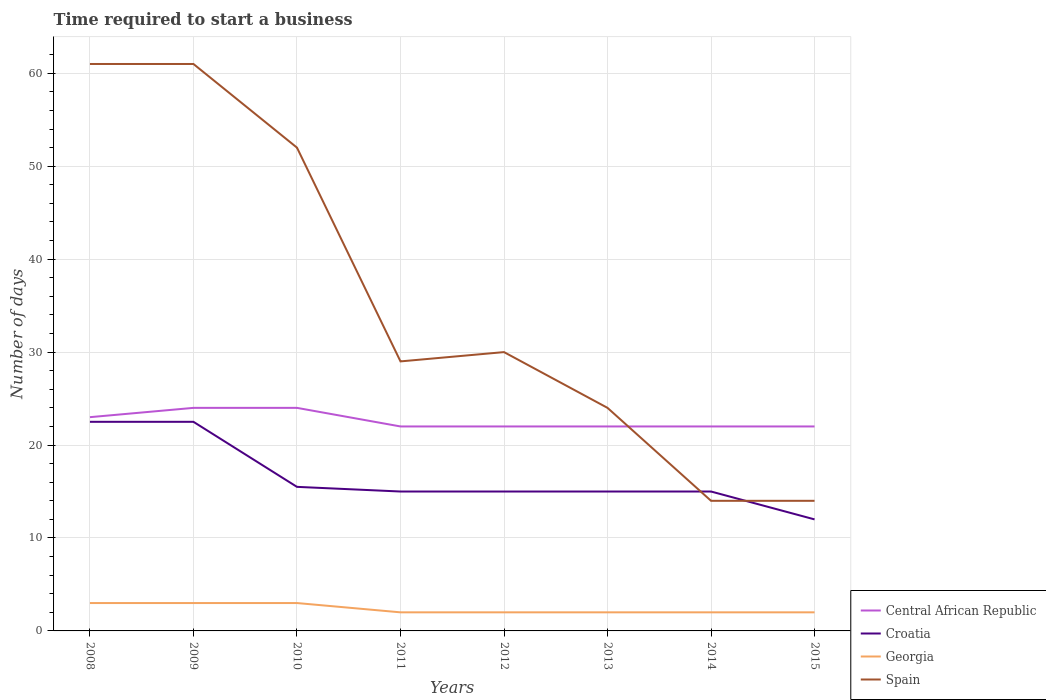Across all years, what is the maximum number of days required to start a business in Georgia?
Provide a succinct answer. 2. What is the total number of days required to start a business in Georgia in the graph?
Keep it short and to the point. 1. What is the difference between the highest and the lowest number of days required to start a business in Spain?
Your answer should be very brief. 3. Is the number of days required to start a business in Spain strictly greater than the number of days required to start a business in Georgia over the years?
Provide a succinct answer. No. Are the values on the major ticks of Y-axis written in scientific E-notation?
Offer a very short reply. No. Does the graph contain any zero values?
Keep it short and to the point. No. How many legend labels are there?
Your answer should be very brief. 4. How are the legend labels stacked?
Provide a short and direct response. Vertical. What is the title of the graph?
Your answer should be very brief. Time required to start a business. Does "Morocco" appear as one of the legend labels in the graph?
Provide a succinct answer. No. What is the label or title of the X-axis?
Offer a terse response. Years. What is the label or title of the Y-axis?
Provide a short and direct response. Number of days. What is the Number of days in Central African Republic in 2009?
Ensure brevity in your answer.  24. What is the Number of days of Georgia in 2009?
Offer a very short reply. 3. What is the Number of days in Spain in 2009?
Keep it short and to the point. 61. What is the Number of days of Georgia in 2010?
Make the answer very short. 3. What is the Number of days in Spain in 2010?
Ensure brevity in your answer.  52. What is the Number of days of Croatia in 2011?
Offer a terse response. 15. What is the Number of days in Central African Republic in 2012?
Give a very brief answer. 22. What is the Number of days of Spain in 2012?
Your answer should be compact. 30. What is the Number of days in Central African Republic in 2013?
Offer a very short reply. 22. What is the Number of days in Croatia in 2013?
Your response must be concise. 15. What is the Number of days in Spain in 2013?
Offer a terse response. 24. What is the Number of days of Croatia in 2014?
Your answer should be very brief. 15. What is the Number of days in Georgia in 2014?
Give a very brief answer. 2. What is the Number of days in Central African Republic in 2015?
Keep it short and to the point. 22. What is the Number of days in Croatia in 2015?
Provide a succinct answer. 12. What is the Number of days in Georgia in 2015?
Provide a succinct answer. 2. Across all years, what is the maximum Number of days of Croatia?
Your response must be concise. 22.5. Across all years, what is the maximum Number of days of Georgia?
Keep it short and to the point. 3. Across all years, what is the minimum Number of days in Central African Republic?
Keep it short and to the point. 22. Across all years, what is the minimum Number of days of Georgia?
Your response must be concise. 2. Across all years, what is the minimum Number of days of Spain?
Ensure brevity in your answer.  14. What is the total Number of days of Central African Republic in the graph?
Provide a short and direct response. 181. What is the total Number of days in Croatia in the graph?
Give a very brief answer. 132.5. What is the total Number of days of Georgia in the graph?
Offer a very short reply. 19. What is the total Number of days in Spain in the graph?
Ensure brevity in your answer.  285. What is the difference between the Number of days in Georgia in 2008 and that in 2010?
Provide a succinct answer. 0. What is the difference between the Number of days of Spain in 2008 and that in 2010?
Offer a terse response. 9. What is the difference between the Number of days of Central African Republic in 2008 and that in 2011?
Provide a succinct answer. 1. What is the difference between the Number of days in Croatia in 2008 and that in 2011?
Provide a short and direct response. 7.5. What is the difference between the Number of days of Georgia in 2008 and that in 2011?
Your answer should be very brief. 1. What is the difference between the Number of days of Spain in 2008 and that in 2012?
Ensure brevity in your answer.  31. What is the difference between the Number of days in Central African Republic in 2008 and that in 2013?
Keep it short and to the point. 1. What is the difference between the Number of days of Croatia in 2008 and that in 2014?
Your answer should be compact. 7.5. What is the difference between the Number of days in Spain in 2008 and that in 2015?
Give a very brief answer. 47. What is the difference between the Number of days of Central African Republic in 2009 and that in 2010?
Offer a very short reply. 0. What is the difference between the Number of days in Croatia in 2009 and that in 2010?
Provide a short and direct response. 7. What is the difference between the Number of days of Georgia in 2009 and that in 2010?
Make the answer very short. 0. What is the difference between the Number of days of Croatia in 2009 and that in 2011?
Your answer should be compact. 7.5. What is the difference between the Number of days of Spain in 2009 and that in 2011?
Ensure brevity in your answer.  32. What is the difference between the Number of days of Central African Republic in 2009 and that in 2012?
Ensure brevity in your answer.  2. What is the difference between the Number of days of Croatia in 2009 and that in 2012?
Make the answer very short. 7.5. What is the difference between the Number of days of Georgia in 2009 and that in 2012?
Keep it short and to the point. 1. What is the difference between the Number of days of Georgia in 2009 and that in 2013?
Provide a succinct answer. 1. What is the difference between the Number of days in Central African Republic in 2009 and that in 2014?
Offer a very short reply. 2. What is the difference between the Number of days in Georgia in 2009 and that in 2014?
Provide a succinct answer. 1. What is the difference between the Number of days of Central African Republic in 2009 and that in 2015?
Ensure brevity in your answer.  2. What is the difference between the Number of days of Spain in 2009 and that in 2015?
Your response must be concise. 47. What is the difference between the Number of days of Central African Republic in 2010 and that in 2011?
Offer a very short reply. 2. What is the difference between the Number of days of Georgia in 2010 and that in 2011?
Offer a very short reply. 1. What is the difference between the Number of days of Spain in 2010 and that in 2011?
Provide a short and direct response. 23. What is the difference between the Number of days in Central African Republic in 2010 and that in 2012?
Give a very brief answer. 2. What is the difference between the Number of days in Spain in 2010 and that in 2012?
Your response must be concise. 22. What is the difference between the Number of days of Central African Republic in 2010 and that in 2013?
Keep it short and to the point. 2. What is the difference between the Number of days in Croatia in 2010 and that in 2013?
Ensure brevity in your answer.  0.5. What is the difference between the Number of days of Spain in 2010 and that in 2013?
Your response must be concise. 28. What is the difference between the Number of days of Central African Republic in 2010 and that in 2014?
Ensure brevity in your answer.  2. What is the difference between the Number of days of Croatia in 2010 and that in 2014?
Keep it short and to the point. 0.5. What is the difference between the Number of days of Spain in 2010 and that in 2014?
Offer a terse response. 38. What is the difference between the Number of days in Central African Republic in 2010 and that in 2015?
Your response must be concise. 2. What is the difference between the Number of days of Central African Republic in 2011 and that in 2012?
Offer a terse response. 0. What is the difference between the Number of days in Croatia in 2011 and that in 2012?
Your response must be concise. 0. What is the difference between the Number of days in Spain in 2011 and that in 2012?
Offer a very short reply. -1. What is the difference between the Number of days in Spain in 2011 and that in 2013?
Make the answer very short. 5. What is the difference between the Number of days in Spain in 2011 and that in 2014?
Ensure brevity in your answer.  15. What is the difference between the Number of days of Croatia in 2011 and that in 2015?
Offer a terse response. 3. What is the difference between the Number of days of Spain in 2011 and that in 2015?
Your response must be concise. 15. What is the difference between the Number of days in Georgia in 2012 and that in 2013?
Offer a very short reply. 0. What is the difference between the Number of days in Spain in 2012 and that in 2014?
Ensure brevity in your answer.  16. What is the difference between the Number of days of Central African Republic in 2012 and that in 2015?
Make the answer very short. 0. What is the difference between the Number of days of Georgia in 2012 and that in 2015?
Your response must be concise. 0. What is the difference between the Number of days in Croatia in 2013 and that in 2014?
Offer a terse response. 0. What is the difference between the Number of days in Georgia in 2013 and that in 2014?
Make the answer very short. 0. What is the difference between the Number of days in Croatia in 2013 and that in 2015?
Offer a terse response. 3. What is the difference between the Number of days in Georgia in 2013 and that in 2015?
Provide a short and direct response. 0. What is the difference between the Number of days of Spain in 2013 and that in 2015?
Your answer should be compact. 10. What is the difference between the Number of days in Central African Republic in 2014 and that in 2015?
Offer a very short reply. 0. What is the difference between the Number of days in Georgia in 2014 and that in 2015?
Your answer should be very brief. 0. What is the difference between the Number of days in Central African Republic in 2008 and the Number of days in Spain in 2009?
Your response must be concise. -38. What is the difference between the Number of days of Croatia in 2008 and the Number of days of Georgia in 2009?
Your answer should be very brief. 19.5. What is the difference between the Number of days in Croatia in 2008 and the Number of days in Spain in 2009?
Give a very brief answer. -38.5. What is the difference between the Number of days in Georgia in 2008 and the Number of days in Spain in 2009?
Make the answer very short. -58. What is the difference between the Number of days in Croatia in 2008 and the Number of days in Georgia in 2010?
Your response must be concise. 19.5. What is the difference between the Number of days of Croatia in 2008 and the Number of days of Spain in 2010?
Your answer should be very brief. -29.5. What is the difference between the Number of days in Georgia in 2008 and the Number of days in Spain in 2010?
Make the answer very short. -49. What is the difference between the Number of days of Central African Republic in 2008 and the Number of days of Georgia in 2011?
Offer a very short reply. 21. What is the difference between the Number of days of Croatia in 2008 and the Number of days of Georgia in 2011?
Your response must be concise. 20.5. What is the difference between the Number of days of Georgia in 2008 and the Number of days of Spain in 2011?
Your answer should be compact. -26. What is the difference between the Number of days of Central African Republic in 2008 and the Number of days of Croatia in 2012?
Offer a very short reply. 8. What is the difference between the Number of days of Central African Republic in 2008 and the Number of days of Georgia in 2012?
Provide a short and direct response. 21. What is the difference between the Number of days in Croatia in 2008 and the Number of days in Spain in 2012?
Provide a short and direct response. -7.5. What is the difference between the Number of days of Georgia in 2008 and the Number of days of Spain in 2012?
Provide a succinct answer. -27. What is the difference between the Number of days in Croatia in 2008 and the Number of days in Georgia in 2013?
Ensure brevity in your answer.  20.5. What is the difference between the Number of days in Georgia in 2008 and the Number of days in Spain in 2013?
Give a very brief answer. -21. What is the difference between the Number of days in Central African Republic in 2008 and the Number of days in Georgia in 2014?
Your answer should be very brief. 21. What is the difference between the Number of days of Central African Republic in 2008 and the Number of days of Spain in 2014?
Keep it short and to the point. 9. What is the difference between the Number of days of Croatia in 2008 and the Number of days of Spain in 2014?
Provide a short and direct response. 8.5. What is the difference between the Number of days in Georgia in 2008 and the Number of days in Spain in 2014?
Provide a short and direct response. -11. What is the difference between the Number of days in Central African Republic in 2008 and the Number of days in Croatia in 2015?
Make the answer very short. 11. What is the difference between the Number of days in Central African Republic in 2008 and the Number of days in Georgia in 2015?
Offer a very short reply. 21. What is the difference between the Number of days in Central African Republic in 2008 and the Number of days in Spain in 2015?
Offer a very short reply. 9. What is the difference between the Number of days in Georgia in 2008 and the Number of days in Spain in 2015?
Give a very brief answer. -11. What is the difference between the Number of days in Central African Republic in 2009 and the Number of days in Croatia in 2010?
Offer a terse response. 8.5. What is the difference between the Number of days of Central African Republic in 2009 and the Number of days of Georgia in 2010?
Make the answer very short. 21. What is the difference between the Number of days of Central African Republic in 2009 and the Number of days of Spain in 2010?
Keep it short and to the point. -28. What is the difference between the Number of days in Croatia in 2009 and the Number of days in Georgia in 2010?
Provide a short and direct response. 19.5. What is the difference between the Number of days of Croatia in 2009 and the Number of days of Spain in 2010?
Offer a terse response. -29.5. What is the difference between the Number of days in Georgia in 2009 and the Number of days in Spain in 2010?
Offer a terse response. -49. What is the difference between the Number of days in Central African Republic in 2009 and the Number of days in Georgia in 2011?
Your response must be concise. 22. What is the difference between the Number of days of Central African Republic in 2009 and the Number of days of Croatia in 2012?
Offer a terse response. 9. What is the difference between the Number of days of Central African Republic in 2009 and the Number of days of Georgia in 2012?
Offer a terse response. 22. What is the difference between the Number of days in Central African Republic in 2009 and the Number of days in Spain in 2012?
Your answer should be very brief. -6. What is the difference between the Number of days in Croatia in 2009 and the Number of days in Spain in 2012?
Give a very brief answer. -7.5. What is the difference between the Number of days of Georgia in 2009 and the Number of days of Spain in 2012?
Provide a succinct answer. -27. What is the difference between the Number of days in Central African Republic in 2009 and the Number of days in Croatia in 2014?
Ensure brevity in your answer.  9. What is the difference between the Number of days in Central African Republic in 2009 and the Number of days in Georgia in 2014?
Provide a short and direct response. 22. What is the difference between the Number of days in Central African Republic in 2009 and the Number of days in Spain in 2014?
Your answer should be very brief. 10. What is the difference between the Number of days of Croatia in 2009 and the Number of days of Georgia in 2014?
Your response must be concise. 20.5. What is the difference between the Number of days in Croatia in 2009 and the Number of days in Spain in 2015?
Give a very brief answer. 8.5. What is the difference between the Number of days in Central African Republic in 2010 and the Number of days in Croatia in 2011?
Offer a very short reply. 9. What is the difference between the Number of days of Central African Republic in 2010 and the Number of days of Georgia in 2011?
Your answer should be very brief. 22. What is the difference between the Number of days of Central African Republic in 2010 and the Number of days of Spain in 2011?
Keep it short and to the point. -5. What is the difference between the Number of days of Croatia in 2010 and the Number of days of Georgia in 2011?
Ensure brevity in your answer.  13.5. What is the difference between the Number of days of Georgia in 2010 and the Number of days of Spain in 2011?
Ensure brevity in your answer.  -26. What is the difference between the Number of days of Central African Republic in 2010 and the Number of days of Spain in 2012?
Provide a short and direct response. -6. What is the difference between the Number of days in Croatia in 2010 and the Number of days in Georgia in 2013?
Make the answer very short. 13.5. What is the difference between the Number of days in Georgia in 2010 and the Number of days in Spain in 2013?
Provide a succinct answer. -21. What is the difference between the Number of days of Georgia in 2010 and the Number of days of Spain in 2014?
Give a very brief answer. -11. What is the difference between the Number of days in Central African Republic in 2010 and the Number of days in Croatia in 2015?
Your answer should be very brief. 12. What is the difference between the Number of days in Central African Republic in 2010 and the Number of days in Spain in 2015?
Offer a terse response. 10. What is the difference between the Number of days of Croatia in 2010 and the Number of days of Spain in 2015?
Make the answer very short. 1.5. What is the difference between the Number of days of Croatia in 2011 and the Number of days of Spain in 2012?
Offer a very short reply. -15. What is the difference between the Number of days in Georgia in 2011 and the Number of days in Spain in 2012?
Your answer should be very brief. -28. What is the difference between the Number of days of Central African Republic in 2011 and the Number of days of Georgia in 2013?
Your answer should be compact. 20. What is the difference between the Number of days in Central African Republic in 2011 and the Number of days in Spain in 2013?
Ensure brevity in your answer.  -2. What is the difference between the Number of days in Croatia in 2011 and the Number of days in Spain in 2013?
Ensure brevity in your answer.  -9. What is the difference between the Number of days in Central African Republic in 2011 and the Number of days in Spain in 2014?
Your answer should be compact. 8. What is the difference between the Number of days of Croatia in 2011 and the Number of days of Georgia in 2015?
Provide a succinct answer. 13. What is the difference between the Number of days of Croatia in 2011 and the Number of days of Spain in 2015?
Offer a terse response. 1. What is the difference between the Number of days of Central African Republic in 2012 and the Number of days of Croatia in 2013?
Your answer should be very brief. 7. What is the difference between the Number of days of Central African Republic in 2012 and the Number of days of Georgia in 2013?
Give a very brief answer. 20. What is the difference between the Number of days of Central African Republic in 2012 and the Number of days of Spain in 2013?
Give a very brief answer. -2. What is the difference between the Number of days in Croatia in 2012 and the Number of days in Georgia in 2013?
Your answer should be compact. 13. What is the difference between the Number of days of Croatia in 2012 and the Number of days of Spain in 2013?
Offer a terse response. -9. What is the difference between the Number of days in Georgia in 2012 and the Number of days in Spain in 2013?
Your answer should be compact. -22. What is the difference between the Number of days of Central African Republic in 2012 and the Number of days of Croatia in 2014?
Give a very brief answer. 7. What is the difference between the Number of days of Central African Republic in 2012 and the Number of days of Georgia in 2014?
Ensure brevity in your answer.  20. What is the difference between the Number of days in Central African Republic in 2012 and the Number of days in Spain in 2014?
Provide a short and direct response. 8. What is the difference between the Number of days in Croatia in 2012 and the Number of days in Spain in 2014?
Keep it short and to the point. 1. What is the difference between the Number of days in Georgia in 2012 and the Number of days in Spain in 2014?
Offer a very short reply. -12. What is the difference between the Number of days in Central African Republic in 2012 and the Number of days in Croatia in 2015?
Your answer should be very brief. 10. What is the difference between the Number of days in Central African Republic in 2012 and the Number of days in Georgia in 2015?
Make the answer very short. 20. What is the difference between the Number of days in Croatia in 2012 and the Number of days in Georgia in 2015?
Offer a very short reply. 13. What is the difference between the Number of days in Croatia in 2012 and the Number of days in Spain in 2015?
Provide a short and direct response. 1. What is the difference between the Number of days of Georgia in 2012 and the Number of days of Spain in 2015?
Ensure brevity in your answer.  -12. What is the difference between the Number of days of Central African Republic in 2013 and the Number of days of Spain in 2014?
Give a very brief answer. 8. What is the difference between the Number of days in Croatia in 2013 and the Number of days in Spain in 2014?
Make the answer very short. 1. What is the difference between the Number of days in Georgia in 2013 and the Number of days in Spain in 2014?
Give a very brief answer. -12. What is the difference between the Number of days in Central African Republic in 2013 and the Number of days in Georgia in 2015?
Ensure brevity in your answer.  20. What is the difference between the Number of days of Croatia in 2013 and the Number of days of Spain in 2015?
Your answer should be compact. 1. What is the difference between the Number of days in Georgia in 2013 and the Number of days in Spain in 2015?
Ensure brevity in your answer.  -12. What is the difference between the Number of days of Central African Republic in 2014 and the Number of days of Croatia in 2015?
Give a very brief answer. 10. What is the difference between the Number of days of Central African Republic in 2014 and the Number of days of Spain in 2015?
Provide a short and direct response. 8. What is the difference between the Number of days in Croatia in 2014 and the Number of days in Georgia in 2015?
Your response must be concise. 13. What is the difference between the Number of days of Croatia in 2014 and the Number of days of Spain in 2015?
Offer a terse response. 1. What is the average Number of days of Central African Republic per year?
Your answer should be very brief. 22.62. What is the average Number of days in Croatia per year?
Provide a succinct answer. 16.56. What is the average Number of days of Georgia per year?
Your response must be concise. 2.38. What is the average Number of days in Spain per year?
Keep it short and to the point. 35.62. In the year 2008, what is the difference between the Number of days in Central African Republic and Number of days in Spain?
Offer a very short reply. -38. In the year 2008, what is the difference between the Number of days in Croatia and Number of days in Georgia?
Give a very brief answer. 19.5. In the year 2008, what is the difference between the Number of days in Croatia and Number of days in Spain?
Give a very brief answer. -38.5. In the year 2008, what is the difference between the Number of days in Georgia and Number of days in Spain?
Your answer should be very brief. -58. In the year 2009, what is the difference between the Number of days in Central African Republic and Number of days in Croatia?
Give a very brief answer. 1.5. In the year 2009, what is the difference between the Number of days in Central African Republic and Number of days in Georgia?
Keep it short and to the point. 21. In the year 2009, what is the difference between the Number of days of Central African Republic and Number of days of Spain?
Provide a succinct answer. -37. In the year 2009, what is the difference between the Number of days in Croatia and Number of days in Georgia?
Keep it short and to the point. 19.5. In the year 2009, what is the difference between the Number of days of Croatia and Number of days of Spain?
Ensure brevity in your answer.  -38.5. In the year 2009, what is the difference between the Number of days of Georgia and Number of days of Spain?
Your answer should be very brief. -58. In the year 2010, what is the difference between the Number of days of Central African Republic and Number of days of Georgia?
Provide a succinct answer. 21. In the year 2010, what is the difference between the Number of days of Central African Republic and Number of days of Spain?
Your answer should be very brief. -28. In the year 2010, what is the difference between the Number of days in Croatia and Number of days in Georgia?
Provide a succinct answer. 12.5. In the year 2010, what is the difference between the Number of days in Croatia and Number of days in Spain?
Make the answer very short. -36.5. In the year 2010, what is the difference between the Number of days in Georgia and Number of days in Spain?
Provide a short and direct response. -49. In the year 2011, what is the difference between the Number of days in Central African Republic and Number of days in Spain?
Your answer should be compact. -7. In the year 2011, what is the difference between the Number of days of Croatia and Number of days of Georgia?
Your answer should be compact. 13. In the year 2012, what is the difference between the Number of days in Croatia and Number of days in Georgia?
Your answer should be compact. 13. In the year 2012, what is the difference between the Number of days in Croatia and Number of days in Spain?
Keep it short and to the point. -15. In the year 2013, what is the difference between the Number of days in Central African Republic and Number of days in Croatia?
Provide a short and direct response. 7. In the year 2013, what is the difference between the Number of days of Central African Republic and Number of days of Spain?
Offer a terse response. -2. In the year 2013, what is the difference between the Number of days in Georgia and Number of days in Spain?
Give a very brief answer. -22. In the year 2014, what is the difference between the Number of days in Central African Republic and Number of days in Croatia?
Keep it short and to the point. 7. In the year 2014, what is the difference between the Number of days of Georgia and Number of days of Spain?
Your answer should be very brief. -12. In the year 2015, what is the difference between the Number of days in Central African Republic and Number of days in Georgia?
Your response must be concise. 20. In the year 2015, what is the difference between the Number of days of Croatia and Number of days of Spain?
Keep it short and to the point. -2. In the year 2015, what is the difference between the Number of days in Georgia and Number of days in Spain?
Keep it short and to the point. -12. What is the ratio of the Number of days in Central African Republic in 2008 to that in 2009?
Your answer should be very brief. 0.96. What is the ratio of the Number of days of Croatia in 2008 to that in 2009?
Your answer should be very brief. 1. What is the ratio of the Number of days in Georgia in 2008 to that in 2009?
Offer a terse response. 1. What is the ratio of the Number of days of Spain in 2008 to that in 2009?
Ensure brevity in your answer.  1. What is the ratio of the Number of days of Croatia in 2008 to that in 2010?
Your answer should be very brief. 1.45. What is the ratio of the Number of days of Georgia in 2008 to that in 2010?
Provide a short and direct response. 1. What is the ratio of the Number of days of Spain in 2008 to that in 2010?
Provide a succinct answer. 1.17. What is the ratio of the Number of days in Central African Republic in 2008 to that in 2011?
Your response must be concise. 1.05. What is the ratio of the Number of days of Spain in 2008 to that in 2011?
Provide a succinct answer. 2.1. What is the ratio of the Number of days of Central African Republic in 2008 to that in 2012?
Give a very brief answer. 1.05. What is the ratio of the Number of days in Georgia in 2008 to that in 2012?
Offer a very short reply. 1.5. What is the ratio of the Number of days of Spain in 2008 to that in 2012?
Provide a succinct answer. 2.03. What is the ratio of the Number of days of Central African Republic in 2008 to that in 2013?
Make the answer very short. 1.05. What is the ratio of the Number of days of Croatia in 2008 to that in 2013?
Your response must be concise. 1.5. What is the ratio of the Number of days of Georgia in 2008 to that in 2013?
Make the answer very short. 1.5. What is the ratio of the Number of days in Spain in 2008 to that in 2013?
Ensure brevity in your answer.  2.54. What is the ratio of the Number of days in Central African Republic in 2008 to that in 2014?
Your answer should be very brief. 1.05. What is the ratio of the Number of days in Georgia in 2008 to that in 2014?
Give a very brief answer. 1.5. What is the ratio of the Number of days in Spain in 2008 to that in 2014?
Make the answer very short. 4.36. What is the ratio of the Number of days in Central African Republic in 2008 to that in 2015?
Your answer should be very brief. 1.05. What is the ratio of the Number of days in Croatia in 2008 to that in 2015?
Ensure brevity in your answer.  1.88. What is the ratio of the Number of days in Spain in 2008 to that in 2015?
Provide a succinct answer. 4.36. What is the ratio of the Number of days of Croatia in 2009 to that in 2010?
Make the answer very short. 1.45. What is the ratio of the Number of days of Georgia in 2009 to that in 2010?
Offer a very short reply. 1. What is the ratio of the Number of days of Spain in 2009 to that in 2010?
Your answer should be very brief. 1.17. What is the ratio of the Number of days in Central African Republic in 2009 to that in 2011?
Offer a terse response. 1.09. What is the ratio of the Number of days in Croatia in 2009 to that in 2011?
Your answer should be compact. 1.5. What is the ratio of the Number of days of Georgia in 2009 to that in 2011?
Offer a very short reply. 1.5. What is the ratio of the Number of days in Spain in 2009 to that in 2011?
Give a very brief answer. 2.1. What is the ratio of the Number of days of Spain in 2009 to that in 2012?
Make the answer very short. 2.03. What is the ratio of the Number of days in Central African Republic in 2009 to that in 2013?
Provide a succinct answer. 1.09. What is the ratio of the Number of days in Georgia in 2009 to that in 2013?
Offer a terse response. 1.5. What is the ratio of the Number of days of Spain in 2009 to that in 2013?
Offer a very short reply. 2.54. What is the ratio of the Number of days in Central African Republic in 2009 to that in 2014?
Keep it short and to the point. 1.09. What is the ratio of the Number of days of Croatia in 2009 to that in 2014?
Your answer should be very brief. 1.5. What is the ratio of the Number of days in Georgia in 2009 to that in 2014?
Offer a very short reply. 1.5. What is the ratio of the Number of days in Spain in 2009 to that in 2014?
Make the answer very short. 4.36. What is the ratio of the Number of days of Croatia in 2009 to that in 2015?
Provide a short and direct response. 1.88. What is the ratio of the Number of days of Georgia in 2009 to that in 2015?
Keep it short and to the point. 1.5. What is the ratio of the Number of days in Spain in 2009 to that in 2015?
Provide a short and direct response. 4.36. What is the ratio of the Number of days of Central African Republic in 2010 to that in 2011?
Your answer should be very brief. 1.09. What is the ratio of the Number of days of Croatia in 2010 to that in 2011?
Provide a succinct answer. 1.03. What is the ratio of the Number of days in Spain in 2010 to that in 2011?
Give a very brief answer. 1.79. What is the ratio of the Number of days in Central African Republic in 2010 to that in 2012?
Provide a short and direct response. 1.09. What is the ratio of the Number of days in Croatia in 2010 to that in 2012?
Make the answer very short. 1.03. What is the ratio of the Number of days in Spain in 2010 to that in 2012?
Provide a succinct answer. 1.73. What is the ratio of the Number of days in Georgia in 2010 to that in 2013?
Provide a succinct answer. 1.5. What is the ratio of the Number of days in Spain in 2010 to that in 2013?
Your response must be concise. 2.17. What is the ratio of the Number of days in Croatia in 2010 to that in 2014?
Your response must be concise. 1.03. What is the ratio of the Number of days of Spain in 2010 to that in 2014?
Provide a succinct answer. 3.71. What is the ratio of the Number of days in Croatia in 2010 to that in 2015?
Your answer should be compact. 1.29. What is the ratio of the Number of days in Spain in 2010 to that in 2015?
Give a very brief answer. 3.71. What is the ratio of the Number of days in Central African Republic in 2011 to that in 2012?
Your response must be concise. 1. What is the ratio of the Number of days in Spain in 2011 to that in 2012?
Offer a very short reply. 0.97. What is the ratio of the Number of days in Spain in 2011 to that in 2013?
Your response must be concise. 1.21. What is the ratio of the Number of days of Central African Republic in 2011 to that in 2014?
Provide a short and direct response. 1. What is the ratio of the Number of days in Spain in 2011 to that in 2014?
Keep it short and to the point. 2.07. What is the ratio of the Number of days of Central African Republic in 2011 to that in 2015?
Your response must be concise. 1. What is the ratio of the Number of days of Croatia in 2011 to that in 2015?
Make the answer very short. 1.25. What is the ratio of the Number of days of Spain in 2011 to that in 2015?
Your answer should be compact. 2.07. What is the ratio of the Number of days in Central African Republic in 2012 to that in 2013?
Give a very brief answer. 1. What is the ratio of the Number of days of Georgia in 2012 to that in 2013?
Give a very brief answer. 1. What is the ratio of the Number of days in Georgia in 2012 to that in 2014?
Your response must be concise. 1. What is the ratio of the Number of days of Spain in 2012 to that in 2014?
Make the answer very short. 2.14. What is the ratio of the Number of days of Georgia in 2012 to that in 2015?
Offer a terse response. 1. What is the ratio of the Number of days in Spain in 2012 to that in 2015?
Offer a terse response. 2.14. What is the ratio of the Number of days in Spain in 2013 to that in 2014?
Keep it short and to the point. 1.71. What is the ratio of the Number of days in Croatia in 2013 to that in 2015?
Keep it short and to the point. 1.25. What is the ratio of the Number of days of Georgia in 2013 to that in 2015?
Your response must be concise. 1. What is the ratio of the Number of days in Spain in 2013 to that in 2015?
Offer a very short reply. 1.71. What is the ratio of the Number of days in Croatia in 2014 to that in 2015?
Provide a short and direct response. 1.25. What is the ratio of the Number of days in Georgia in 2014 to that in 2015?
Provide a succinct answer. 1. What is the ratio of the Number of days in Spain in 2014 to that in 2015?
Make the answer very short. 1. What is the difference between the highest and the second highest Number of days of Croatia?
Offer a very short reply. 0. What is the difference between the highest and the second highest Number of days of Spain?
Ensure brevity in your answer.  0. What is the difference between the highest and the lowest Number of days of Central African Republic?
Keep it short and to the point. 2. What is the difference between the highest and the lowest Number of days of Croatia?
Provide a short and direct response. 10.5. What is the difference between the highest and the lowest Number of days in Georgia?
Make the answer very short. 1. What is the difference between the highest and the lowest Number of days in Spain?
Keep it short and to the point. 47. 